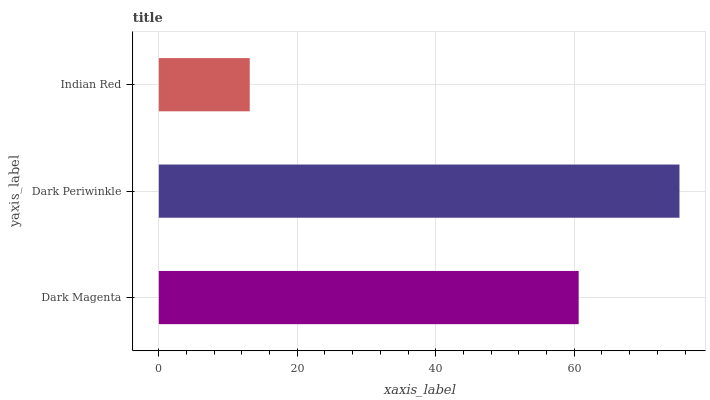Is Indian Red the minimum?
Answer yes or no. Yes. Is Dark Periwinkle the maximum?
Answer yes or no. Yes. Is Dark Periwinkle the minimum?
Answer yes or no. No. Is Indian Red the maximum?
Answer yes or no. No. Is Dark Periwinkle greater than Indian Red?
Answer yes or no. Yes. Is Indian Red less than Dark Periwinkle?
Answer yes or no. Yes. Is Indian Red greater than Dark Periwinkle?
Answer yes or no. No. Is Dark Periwinkle less than Indian Red?
Answer yes or no. No. Is Dark Magenta the high median?
Answer yes or no. Yes. Is Dark Magenta the low median?
Answer yes or no. Yes. Is Dark Periwinkle the high median?
Answer yes or no. No. Is Indian Red the low median?
Answer yes or no. No. 